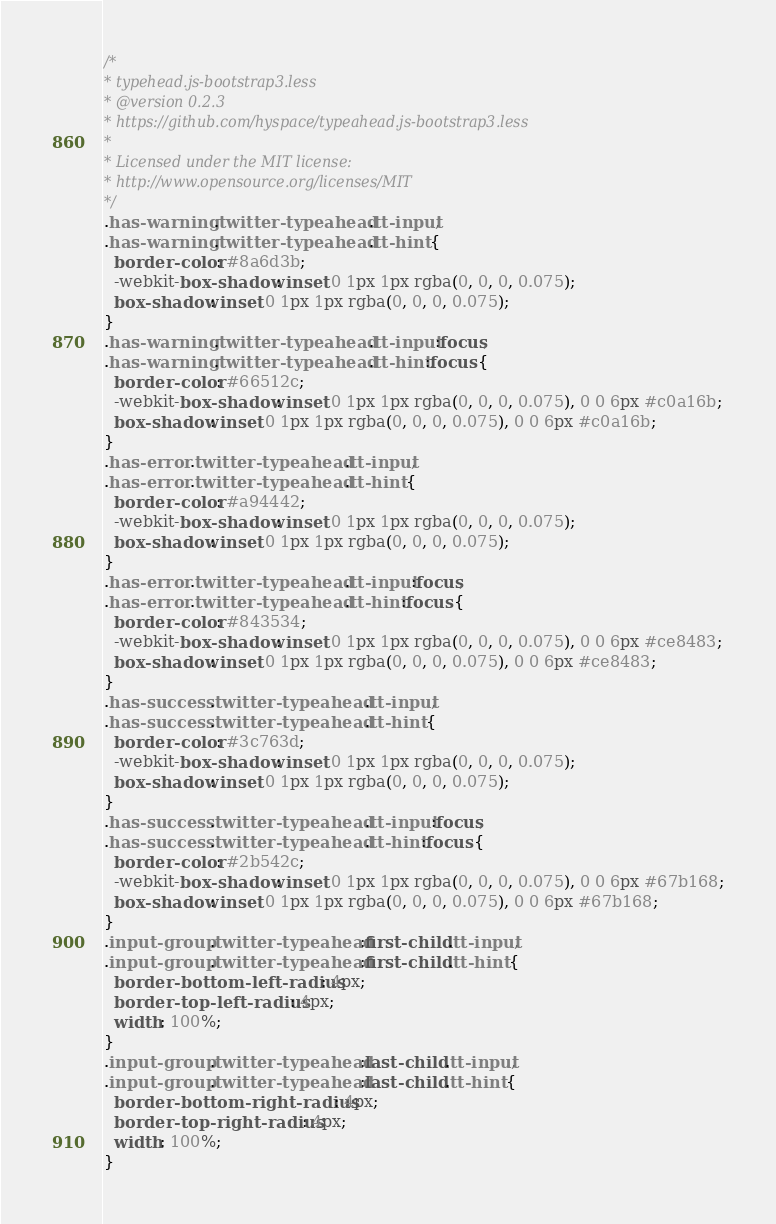<code> <loc_0><loc_0><loc_500><loc_500><_CSS_>/*
* typehead.js-bootstrap3.less
* @version 0.2.3
* https://github.com/hyspace/typeahead.js-bootstrap3.less
*
* Licensed under the MIT license:
* http://www.opensource.org/licenses/MIT
*/
.has-warning .twitter-typeahead .tt-input,
.has-warning .twitter-typeahead .tt-hint {
  border-color: #8a6d3b;
  -webkit-box-shadow: inset 0 1px 1px rgba(0, 0, 0, 0.075);
  box-shadow: inset 0 1px 1px rgba(0, 0, 0, 0.075);
}
.has-warning .twitter-typeahead .tt-input:focus,
.has-warning .twitter-typeahead .tt-hint:focus {
  border-color: #66512c;
  -webkit-box-shadow: inset 0 1px 1px rgba(0, 0, 0, 0.075), 0 0 6px #c0a16b;
  box-shadow: inset 0 1px 1px rgba(0, 0, 0, 0.075), 0 0 6px #c0a16b;
}
.has-error .twitter-typeahead .tt-input,
.has-error .twitter-typeahead .tt-hint {
  border-color: #a94442;
  -webkit-box-shadow: inset 0 1px 1px rgba(0, 0, 0, 0.075);
  box-shadow: inset 0 1px 1px rgba(0, 0, 0, 0.075);
}
.has-error .twitter-typeahead .tt-input:focus,
.has-error .twitter-typeahead .tt-hint:focus {
  border-color: #843534;
  -webkit-box-shadow: inset 0 1px 1px rgba(0, 0, 0, 0.075), 0 0 6px #ce8483;
  box-shadow: inset 0 1px 1px rgba(0, 0, 0, 0.075), 0 0 6px #ce8483;
}
.has-success .twitter-typeahead .tt-input,
.has-success .twitter-typeahead .tt-hint {
  border-color: #3c763d;
  -webkit-box-shadow: inset 0 1px 1px rgba(0, 0, 0, 0.075);
  box-shadow: inset 0 1px 1px rgba(0, 0, 0, 0.075);
}
.has-success .twitter-typeahead .tt-input:focus,
.has-success .twitter-typeahead .tt-hint:focus {
  border-color: #2b542c;
  -webkit-box-shadow: inset 0 1px 1px rgba(0, 0, 0, 0.075), 0 0 6px #67b168;
  box-shadow: inset 0 1px 1px rgba(0, 0, 0, 0.075), 0 0 6px #67b168;
}
.input-group .twitter-typeahead:first-child .tt-input,
.input-group .twitter-typeahead:first-child .tt-hint {
  border-bottom-left-radius: 4px;
  border-top-left-radius: 4px;
  width: 100%;
}
.input-group .twitter-typeahead:last-child .tt-input,
.input-group .twitter-typeahead:last-child .tt-hint {
  border-bottom-right-radius: 4px;
  border-top-right-radius: 4px;
  width: 100%;
}</code> 